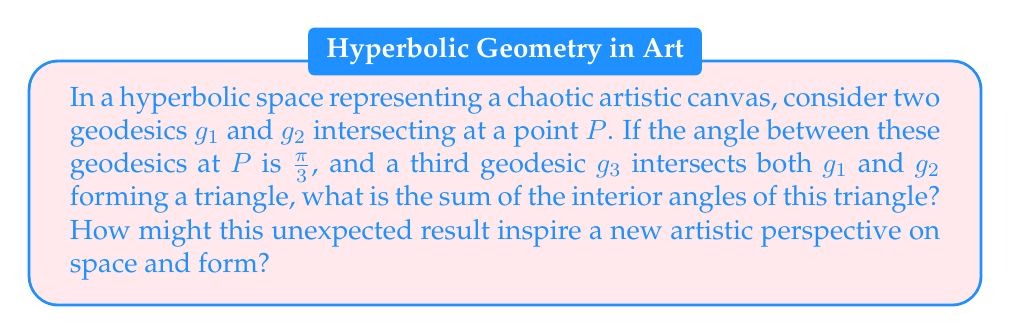Give your solution to this math problem. Let's approach this step-by-step:

1) In Euclidean geometry, we know that the sum of interior angles of a triangle is always $\pi$ radians or 180°. However, in hyperbolic geometry, this is not the case.

2) In hyperbolic geometry, the sum of the interior angles of a triangle is always less than $\pi$ radians. This is a key property of hyperbolic space.

3) The degree of deviation from $\pi$ is related to the area of the triangle. The larger the triangle, the smaller the sum of its angles.

4) The precise relationship is given by the Gauss-Bonnet theorem for hyperbolic triangles:

   $$A = \pi - (\alpha + \beta + \gamma)$$

   where $A$ is the area of the triangle and $\alpha$, $\beta$, and $\gamma$ are the interior angles.

5) We're given that one of the angles (let's call it $\alpha$) is $\frac{\pi}{3}$. We don't know the other two angles, but we know their sum is less than $\frac{2\pi}{3}$.

6) Without more information about the specific geodesics or the size of the triangle, we can't determine the exact sum. We can only say that:

   $$0 < \alpha + \beta + \gamma < \pi$$

   and more specifically:

   $$\frac{\pi}{3} < \alpha + \beta + \gamma < \pi$$

7) This result challenges our Euclidean intuition about space and angles. In an artistic context, it suggests that in this hyperbolic "canvas," traditional spatial relationships are warped. Straight lines (geodesics) can intersect in unexpected ways, creating triangles with angle sums that defy our usual understanding.

8) This could inspire artistic explorations of curved space, where traditional perspective and form are reimagined. It might lead to works that play with the viewer's perception of space, creating impossible-seeming geometries that reflect the underlying hyperbolic structure.
Answer: $\frac{\pi}{3} < \text{sum of angles} < \pi$ 